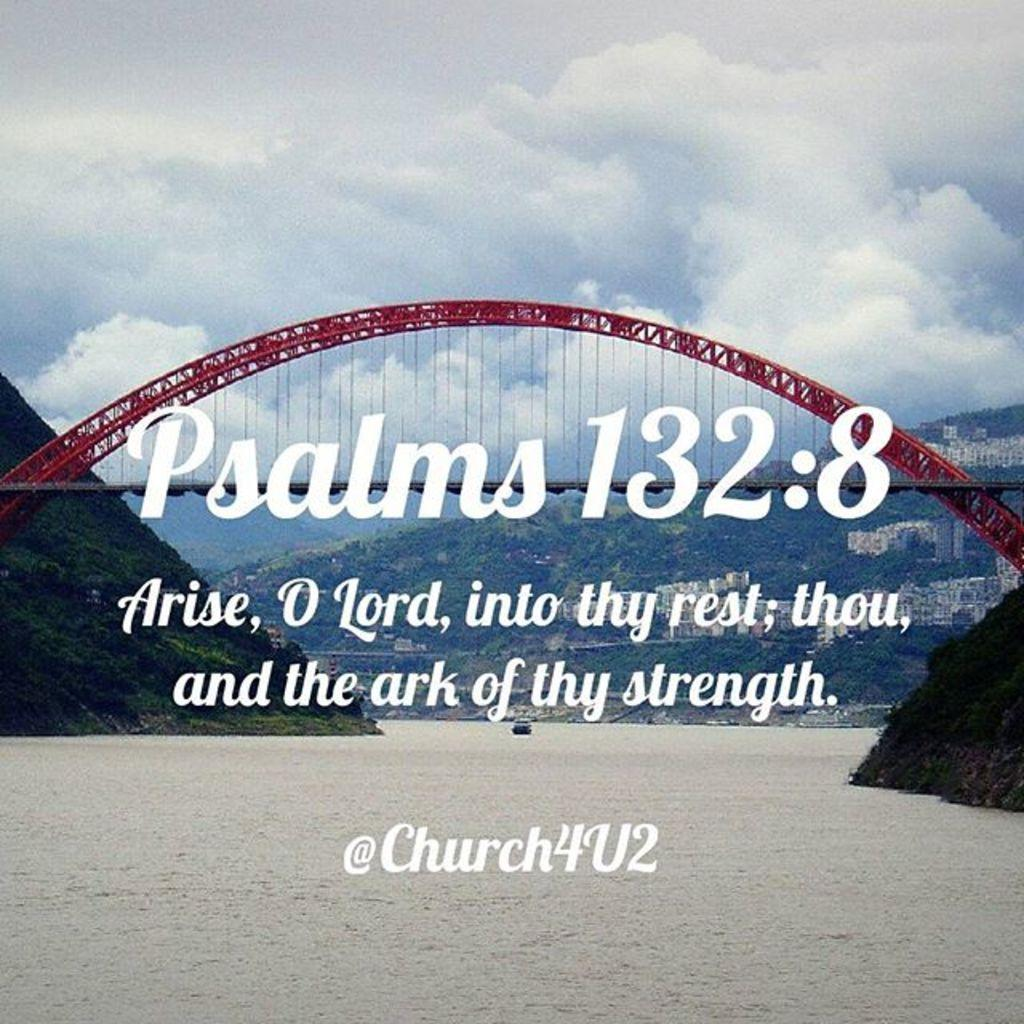<image>
Present a compact description of the photo's key features. A PICTURE OF A RED BRIDGE OVER WATER WITH A PSALM SAYING 